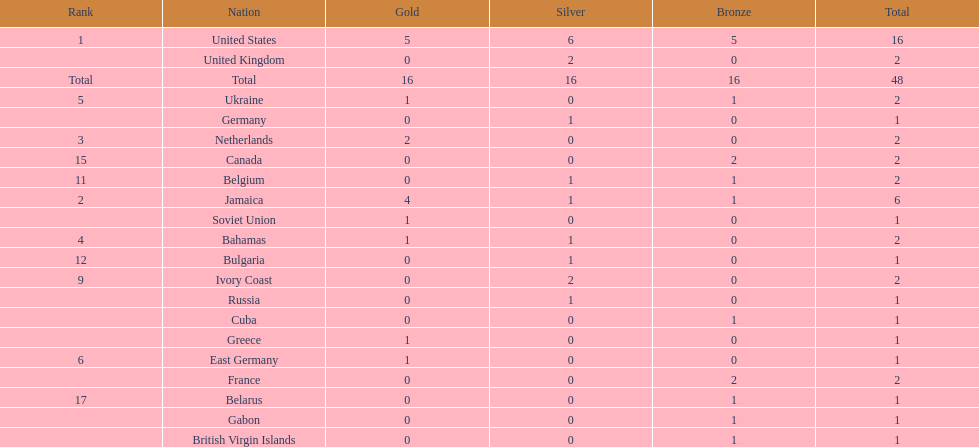How many nations won more than one silver medal? 3. 